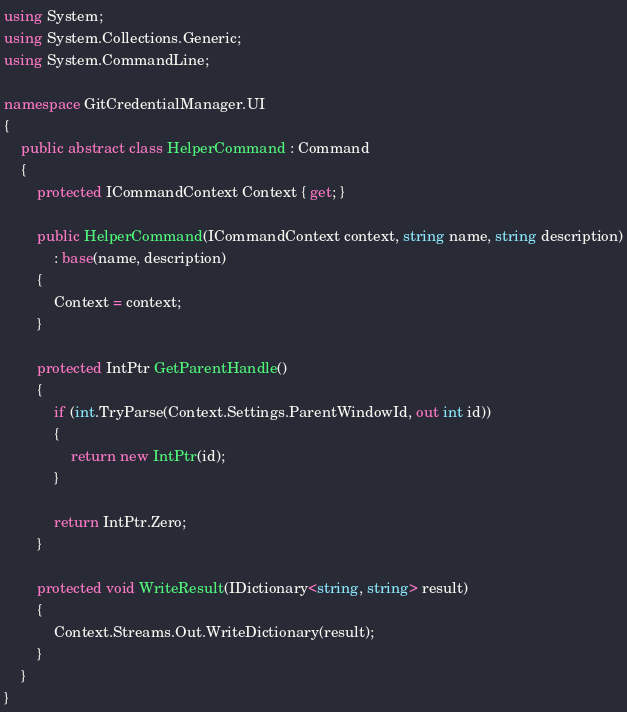<code> <loc_0><loc_0><loc_500><loc_500><_C#_>using System;
using System.Collections.Generic;
using System.CommandLine;

namespace GitCredentialManager.UI
{
    public abstract class HelperCommand : Command
    {
        protected ICommandContext Context { get; }

        public HelperCommand(ICommandContext context, string name, string description)
            : base(name, description)
        {
            Context = context;
        }

        protected IntPtr GetParentHandle()
        {
            if (int.TryParse(Context.Settings.ParentWindowId, out int id))
            {
                return new IntPtr(id);
            }

            return IntPtr.Zero;
        }

        protected void WriteResult(IDictionary<string, string> result)
        {
            Context.Streams.Out.WriteDictionary(result);
        }
    }
}
</code> 